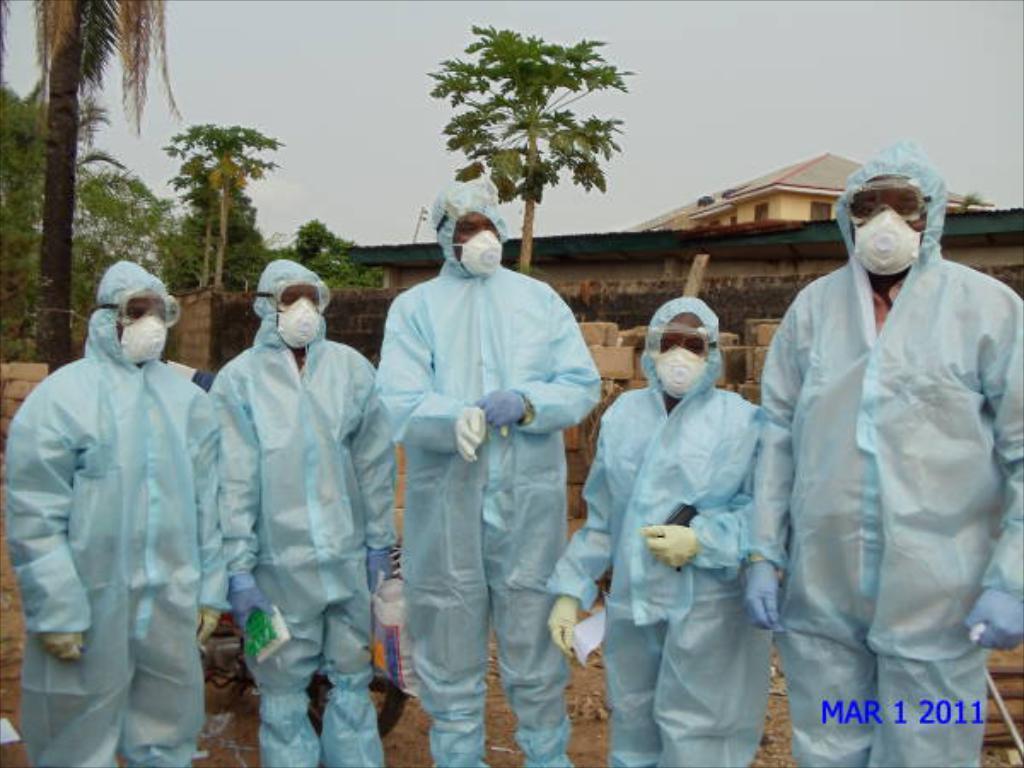Can you describe this image briefly? In this image I can see few people wearing the blue color dresses and also these people with white color mask. In the back I can see the house, trees and the white sky. 